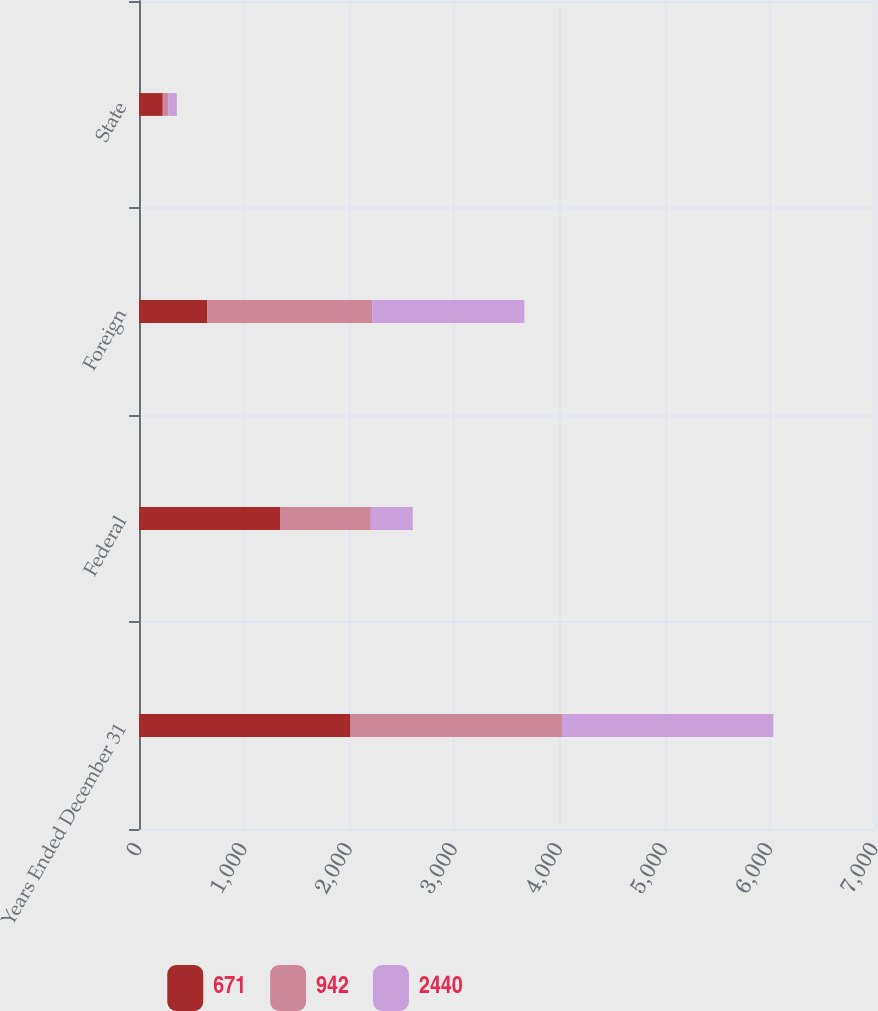Convert chart to OTSL. <chart><loc_0><loc_0><loc_500><loc_500><stacked_bar_chart><ecel><fcel>Years Ended December 31<fcel>Federal<fcel>Foreign<fcel>State<nl><fcel>671<fcel>2012<fcel>1346<fcel>651<fcel>226<nl><fcel>942<fcel>2011<fcel>859<fcel>1568<fcel>52<nl><fcel>2440<fcel>2010<fcel>399<fcel>1446<fcel>82<nl></chart> 